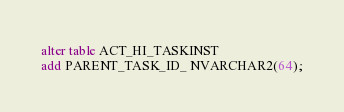Convert code to text. <code><loc_0><loc_0><loc_500><loc_500><_SQL_>alter table ACT_HI_TASKINST
add PARENT_TASK_ID_ NVARCHAR2(64);
</code> 